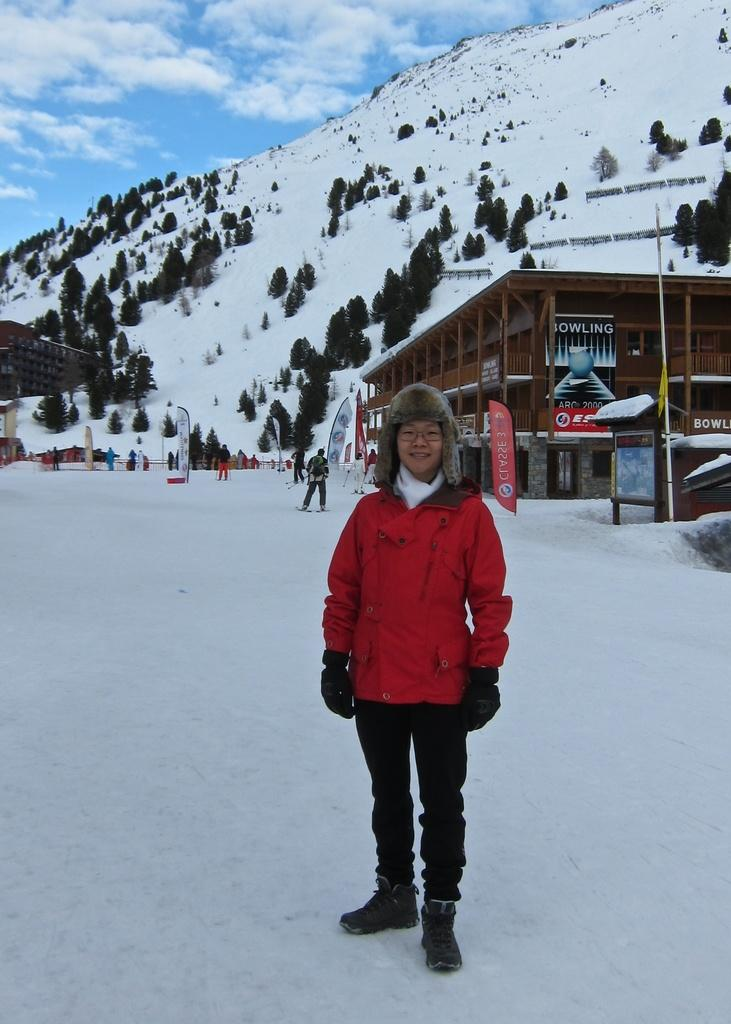What is the person in the image wearing? The person is wearing a red dress. What is the person standing on in the image? The person is standing on snow. What can be seen behind the person in the image? There is a building behind the person. What natural feature is visible in the distance in the image? There is a mountain covered with snow in the image, and trees can be seen on the mountain. Where is the needle located in the image? There is no needle present in the image. Can you describe the sofa in the image? There is no sofa present in the image. 